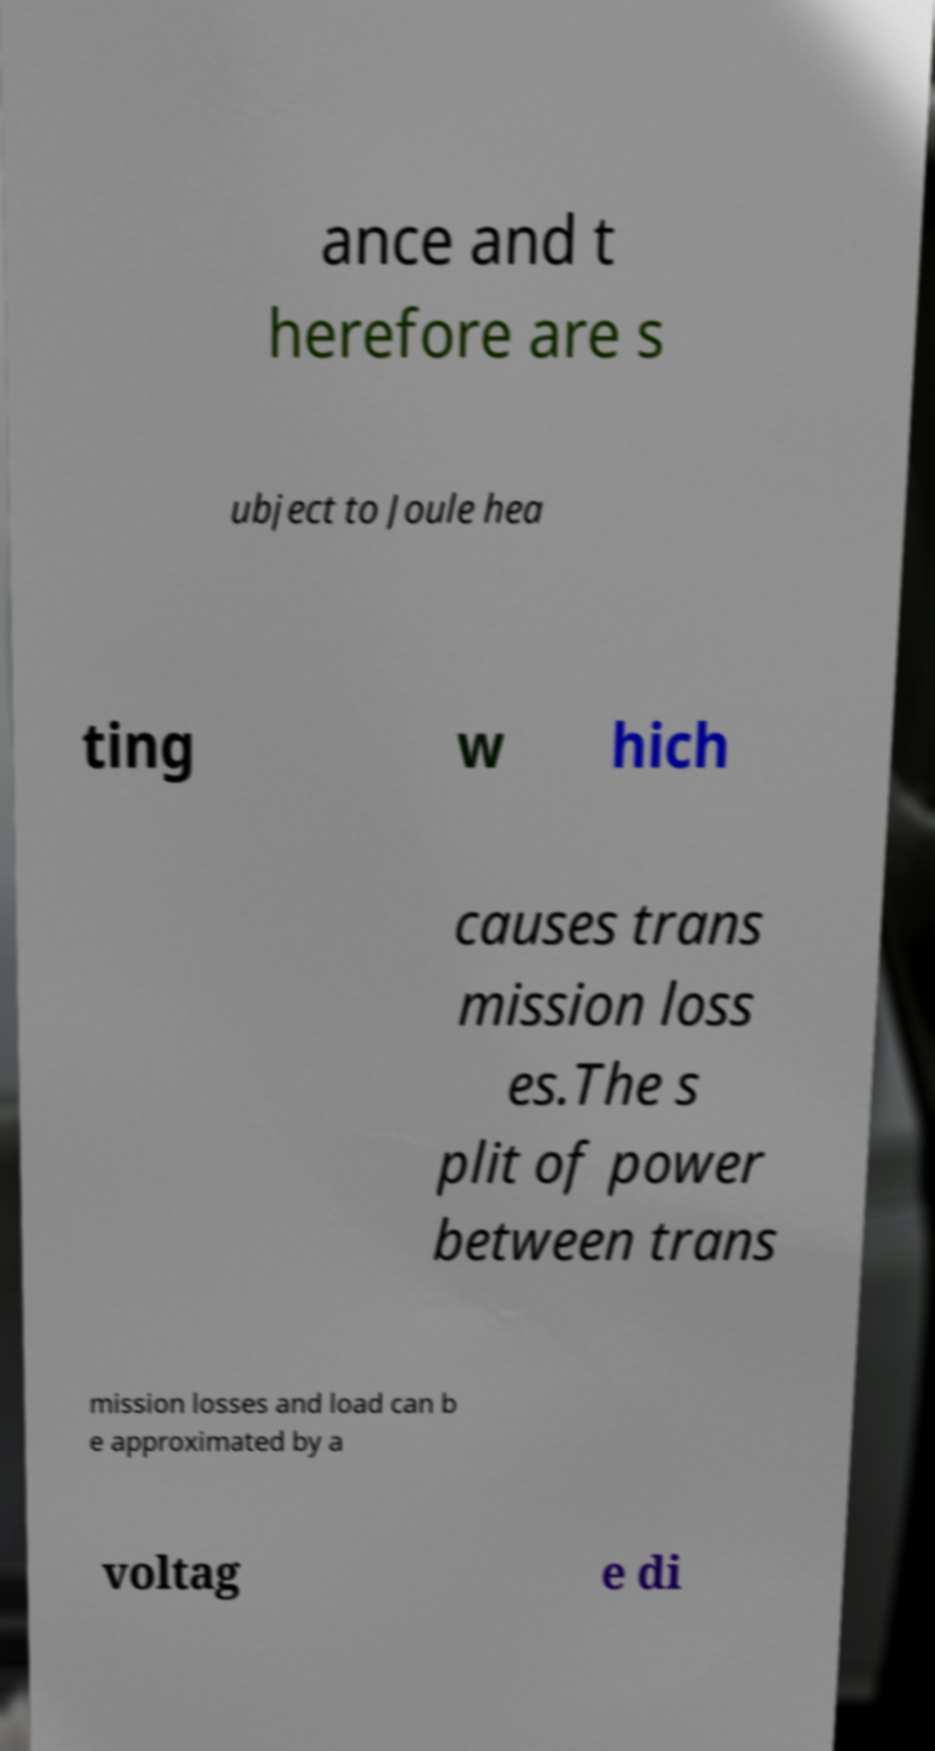What messages or text are displayed in this image? I need them in a readable, typed format. ance and t herefore are s ubject to Joule hea ting w hich causes trans mission loss es.The s plit of power between trans mission losses and load can b e approximated by a voltag e di 